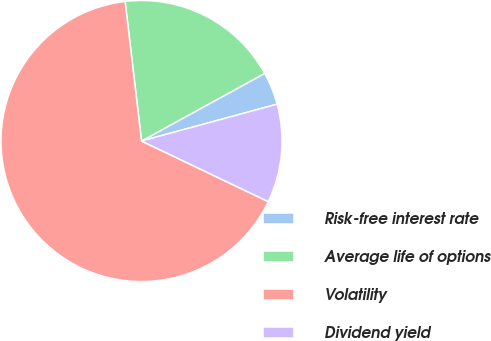Convert chart to OTSL. <chart><loc_0><loc_0><loc_500><loc_500><pie_chart><fcel>Risk-free interest rate<fcel>Average life of options<fcel>Volatility<fcel>Dividend yield<nl><fcel>3.77%<fcel>18.87%<fcel>66.04%<fcel>11.32%<nl></chart> 